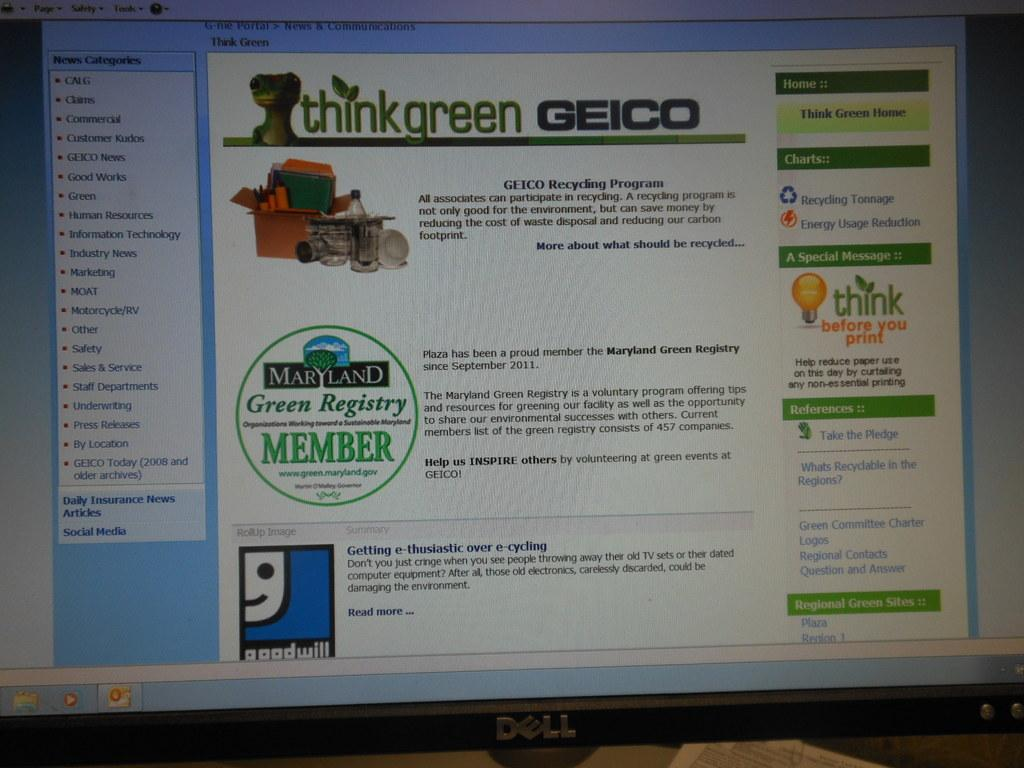<image>
Create a compact narrative representing the image presented. A screen shows an ad from Geico that details a recycling program. 